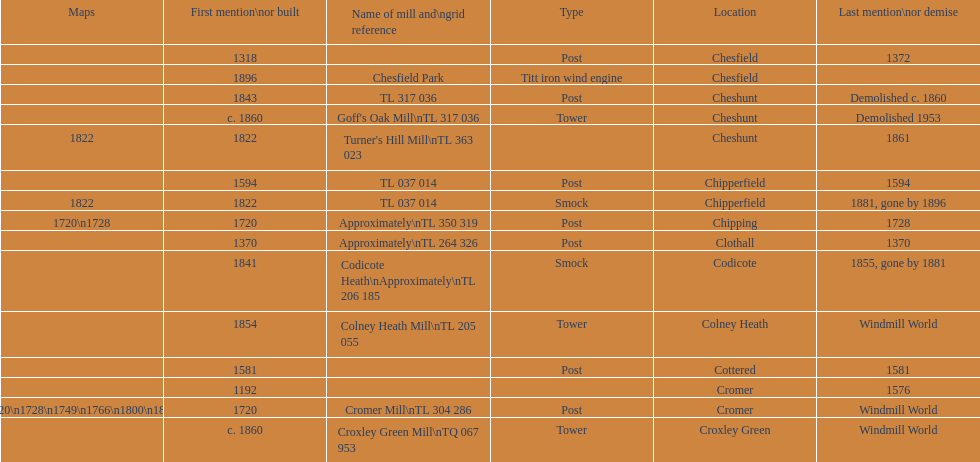What location has the most maps? Cromer. 